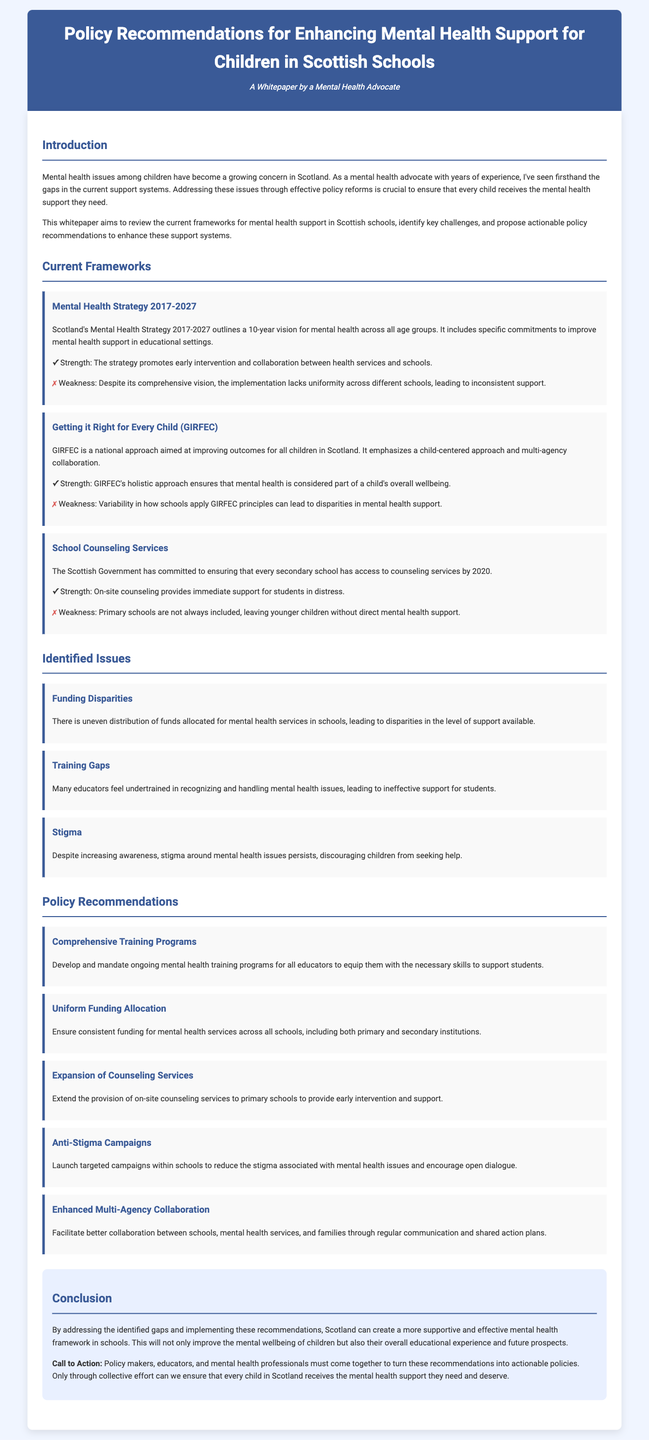What is the title of the whitepaper? The title is prominently displayed at the top of the document, indicating the focus on enhancing mental health support for children in schools.
Answer: Policy Recommendations for Enhancing Mental Health Support for Children in Scottish Schools What year does Scotland's Mental Health Strategy cover until? The whitepaper specifies the duration of the strategy, which is from 2017 into the future.
Answer: 2027 Which approach emphasizes a child-centered approach? The document discusses various frameworks, and one specifically focuses on improving outcomes for children through a holistic method.
Answer: Getting it Right for Every Child (GIRFEC) What is one identified issue regarding mental health support in schools? The document outlines several challenges, one of which deals with how resources are distributed for mental health services in educational settings.
Answer: Funding Disparities How many policy recommendations are proposed in the whitepaper? The recommendations are clearly listed, providing a straightforward count of the suggestions made for improving mental health support.
Answer: Five What is one strength of the School Counseling Services? The document highlights the benefits of having counseling services available within secondary schools specifically.
Answer: Immediate support for students in distress What kind of campaigns does the whitepaper recommend launching? The proposals include efforts aimed at changing perceptions about mental health to encourage children to seek help.
Answer: Anti-Stigma Campaigns What is the main call to action in the conclusion? The conclusion ties together the need for collaboration and action from various stakeholders in the education and mental health sectors.
Answer: Collective effort 